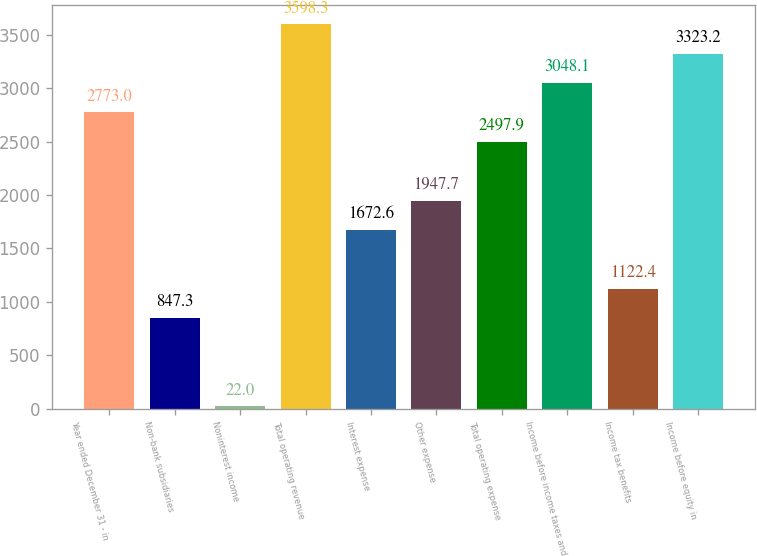Convert chart to OTSL. <chart><loc_0><loc_0><loc_500><loc_500><bar_chart><fcel>Year ended December 31 - in<fcel>Non-bank subsidiaries<fcel>Noninterest income<fcel>Total operating revenue<fcel>Interest expense<fcel>Other expense<fcel>Total operating expense<fcel>Income before income taxes and<fcel>Income tax benefits<fcel>Income before equity in<nl><fcel>2773<fcel>847.3<fcel>22<fcel>3598.3<fcel>1672.6<fcel>1947.7<fcel>2497.9<fcel>3048.1<fcel>1122.4<fcel>3323.2<nl></chart> 